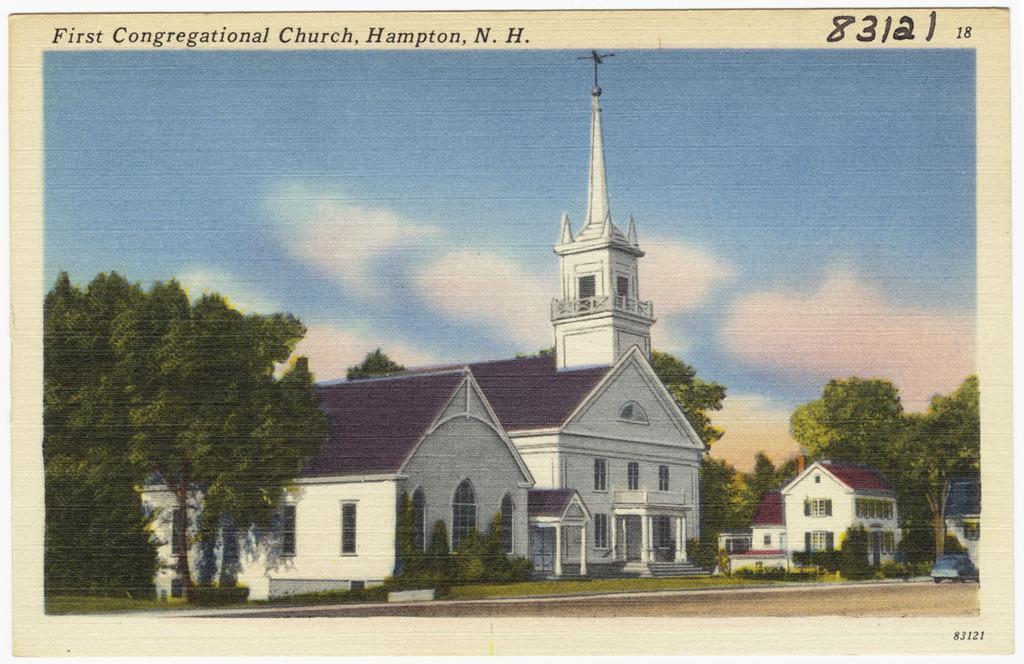How would you summarize this image in a sentence or two? This image is a painting. On the right side of the image we can see buildings and trees. On the left side there are trees. In the background there is a sky and clouds. 